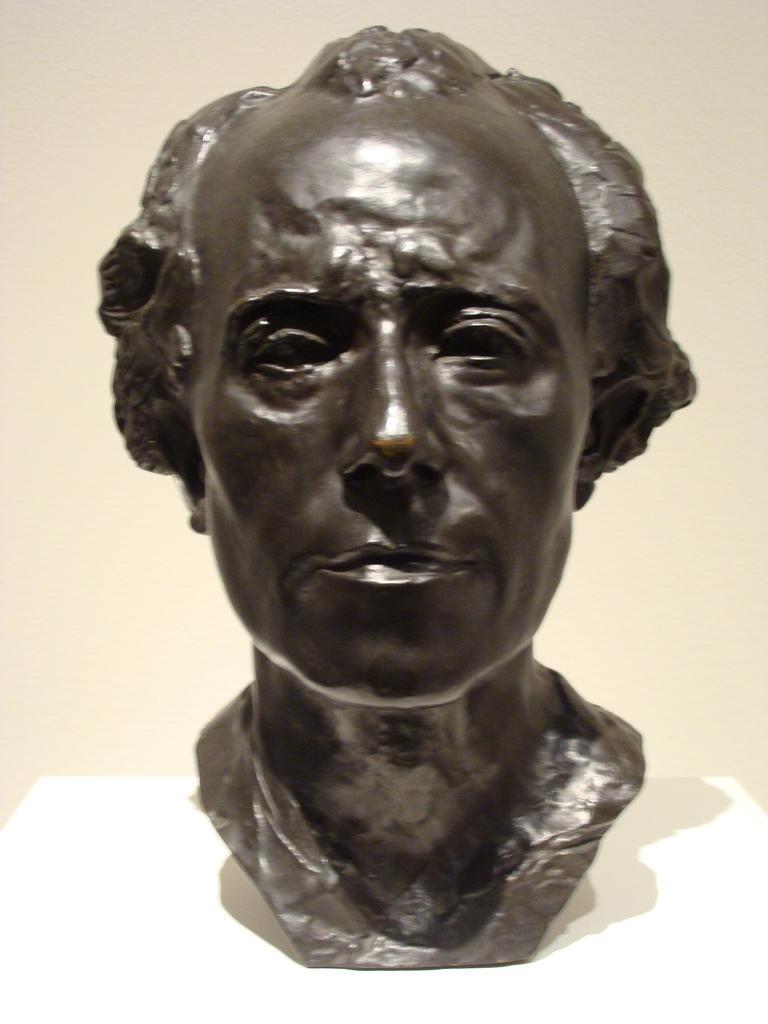Please provide a concise description of this image. In this image we can see statue of person's head on a white object. 